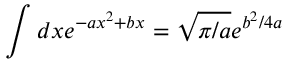<formula> <loc_0><loc_0><loc_500><loc_500>\int d x e ^ { - a x ^ { 2 } + b x } = \sqrt { \pi / a } e ^ { b ^ { 2 } / 4 a }</formula> 